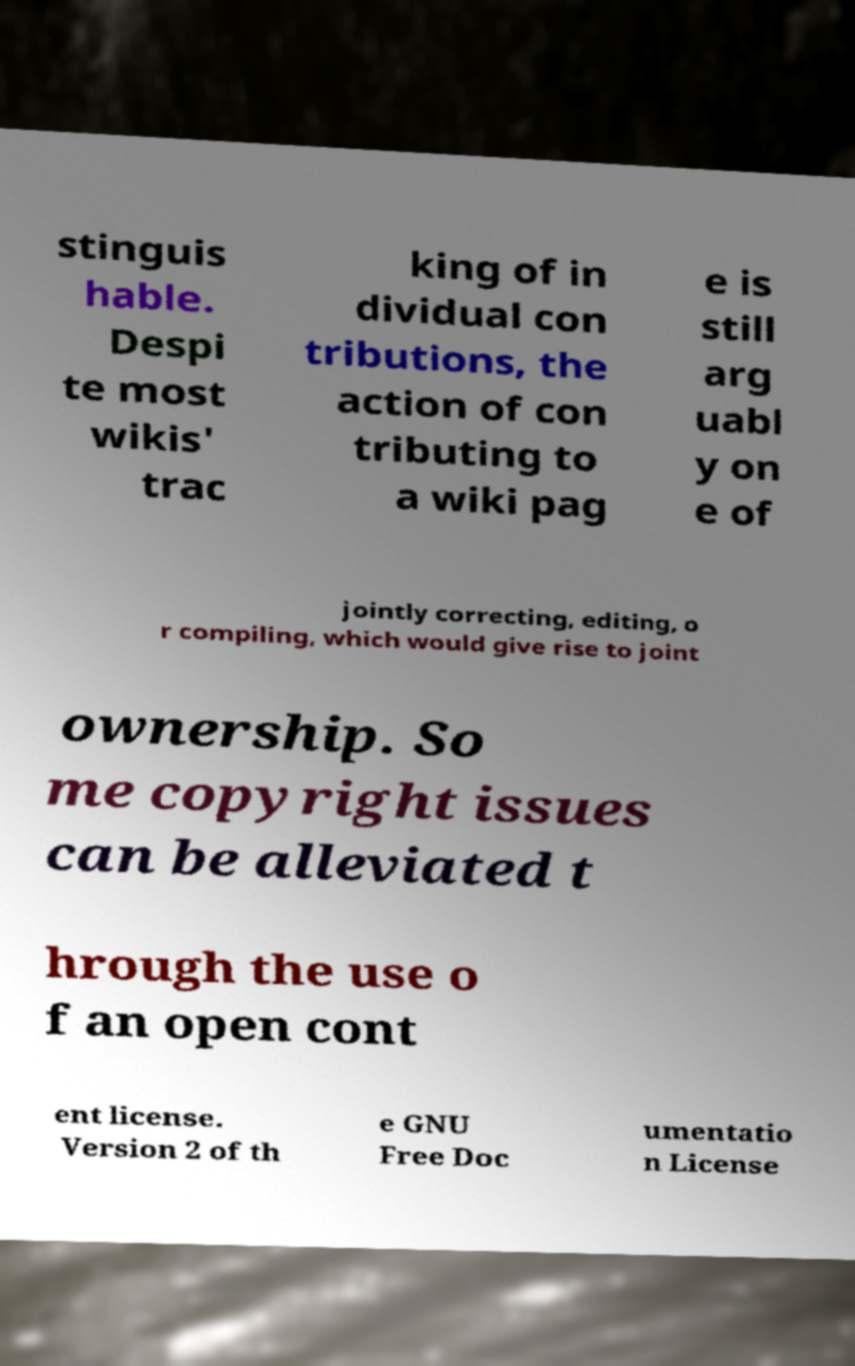Could you assist in decoding the text presented in this image and type it out clearly? stinguis hable. Despi te most wikis' trac king of in dividual con tributions, the action of con tributing to a wiki pag e is still arg uabl y on e of jointly correcting, editing, o r compiling, which would give rise to joint ownership. So me copyright issues can be alleviated t hrough the use o f an open cont ent license. Version 2 of th e GNU Free Doc umentatio n License 